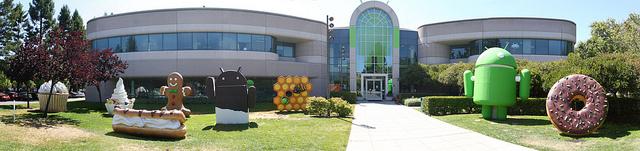What company does the green robot stand for?
Keep it brief. Android. Is this an interior?
Answer briefly. No. How many giant baked goods are on the grass?
Short answer required. 3. 